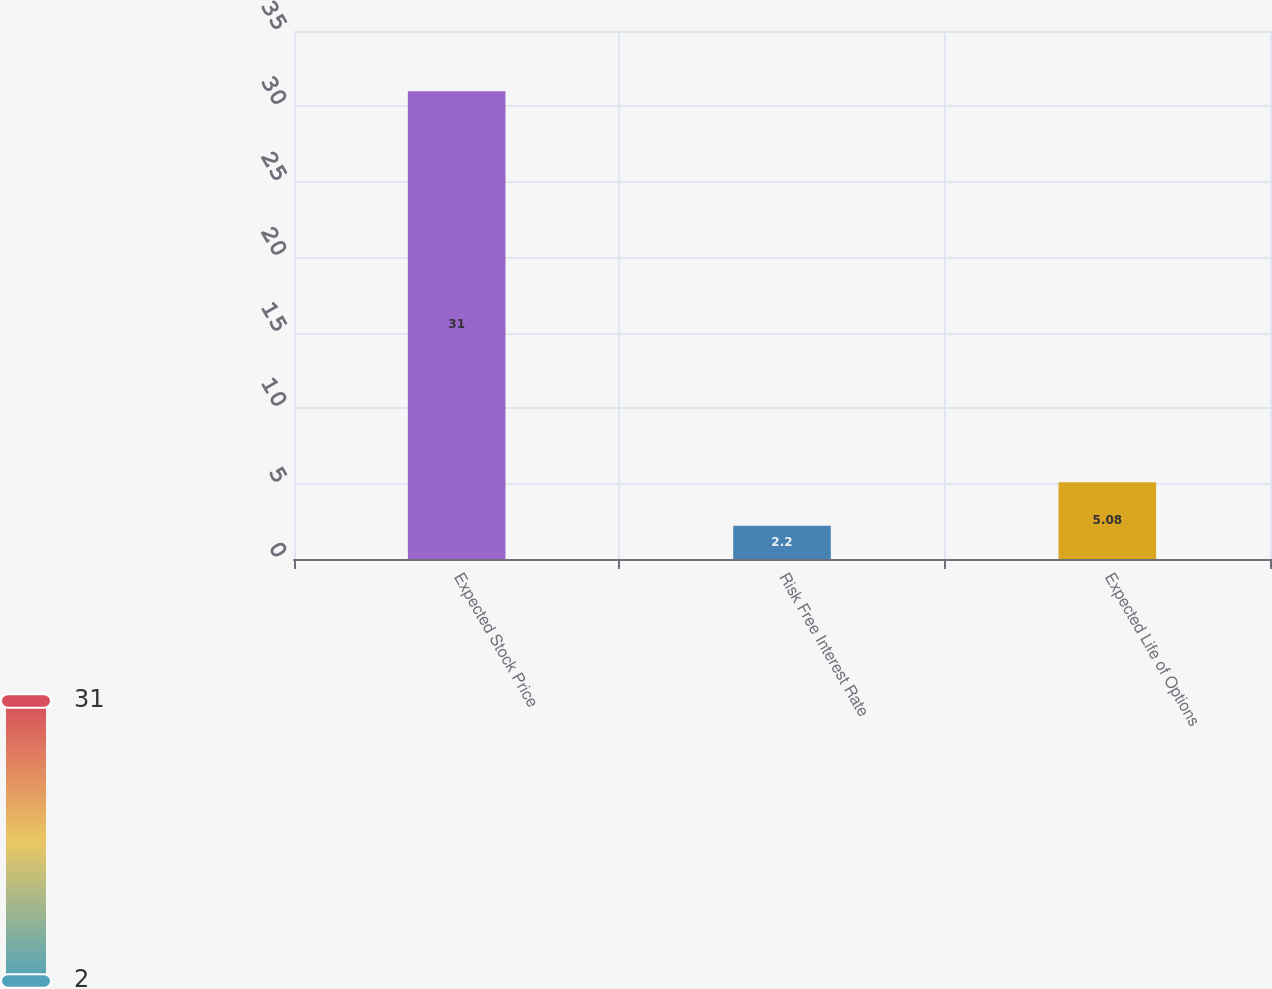Convert chart to OTSL. <chart><loc_0><loc_0><loc_500><loc_500><bar_chart><fcel>Expected Stock Price<fcel>Risk Free Interest Rate<fcel>Expected Life of Options<nl><fcel>31<fcel>2.2<fcel>5.08<nl></chart> 